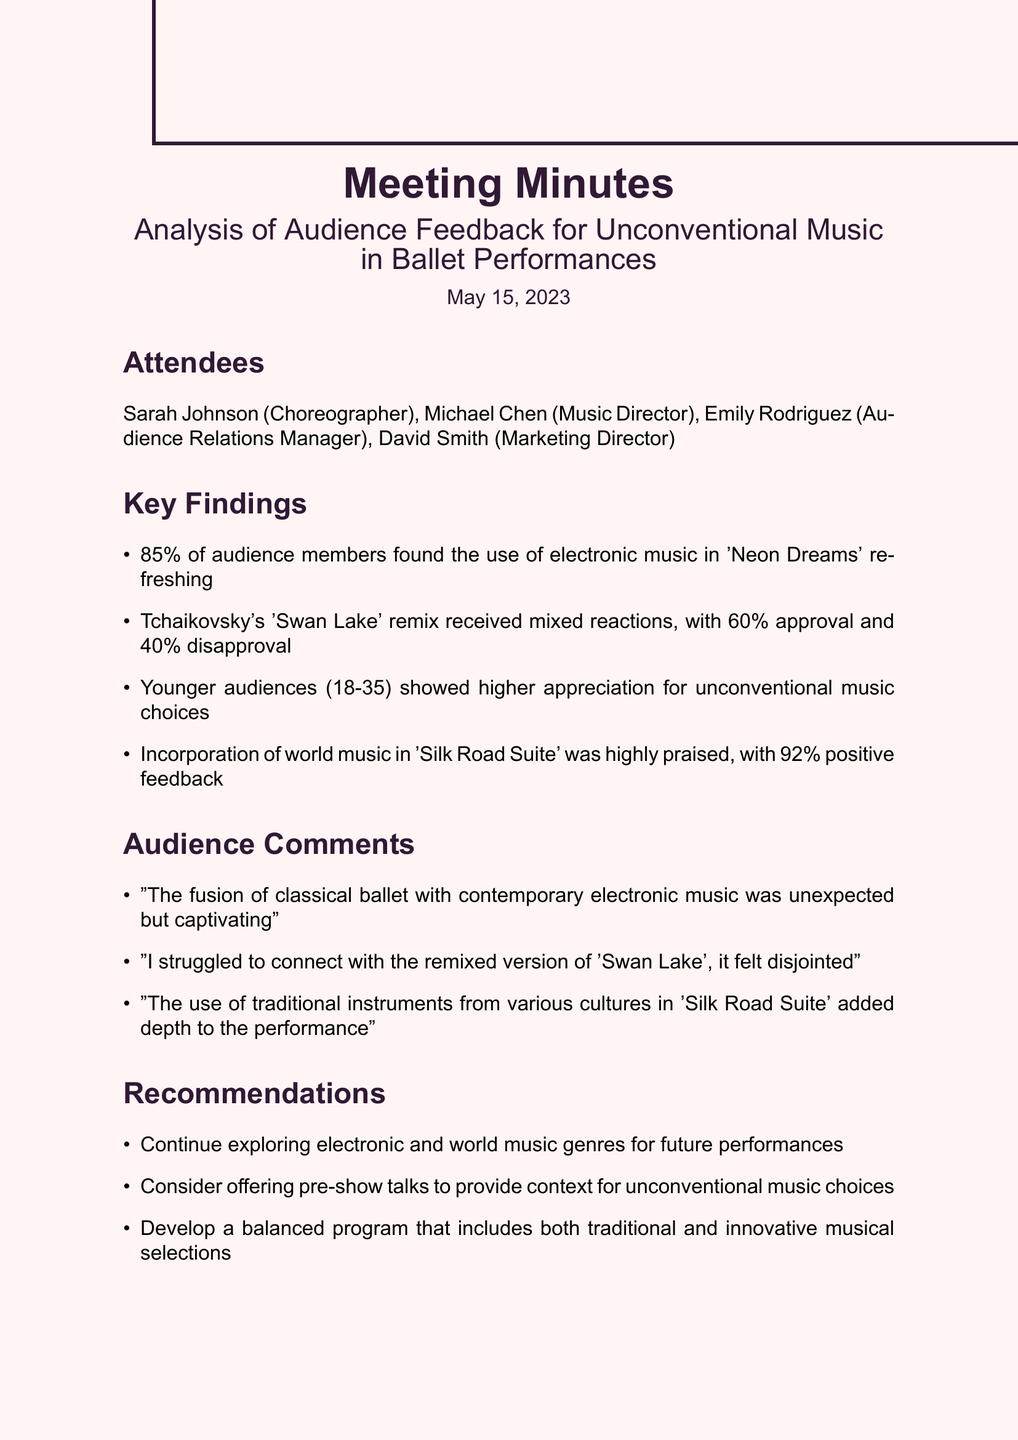what is the date of the meeting? The date of the meeting is specified in the document.
Answer: May 15, 2023 who is the Music Director? The document lists attendees, including their roles.
Answer: Michael Chen what percentage of the audience found the electronic music in 'Neon Dreams' refreshing? The document provides key findings related to audience feedback on music.
Answer: 85% which performance received 60% approval? The document mentions specific performances and their audience reactions.
Answer: Tchaikovsky's 'Swan Lake' remix what type of music was highly praised in 'Silk Road Suite'? The audience comments reflect their feedback on music choices in performances.
Answer: world music why might younger audiences respond better to unconventional music choices? The document notes a demographic trend regarding audience feedback on music.
Answer: higher appreciation what is one of the recommendations for future performances? The document outlines suggestions for enhancing future performances based on feedback.
Answer: Continue exploring electronic and world music genres when is the next meeting scheduled? The document indicates the date for the next scheduled meeting.
Answer: June 1, 2023 